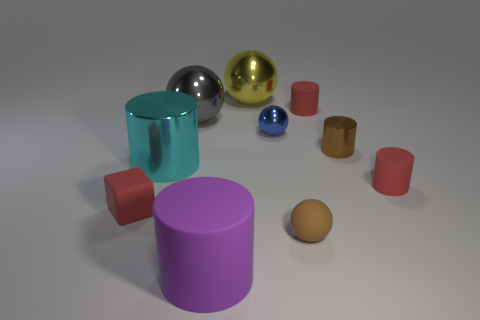Are there any red rubber cubes in front of the red matte object left of the tiny brown rubber thing?
Make the answer very short. No. What number of other things are there of the same color as the tiny rubber cube?
Your answer should be very brief. 2. The rubber ball is what color?
Provide a short and direct response. Brown. How big is the thing that is both behind the big purple cylinder and in front of the red block?
Your answer should be compact. Small. What number of objects are matte objects right of the cyan metallic object or big blue cubes?
Make the answer very short. 4. There is a purple thing that is made of the same material as the red cube; what is its shape?
Your answer should be compact. Cylinder. What is the shape of the purple rubber thing?
Your response must be concise. Cylinder. What is the color of the sphere that is on the left side of the blue object and in front of the yellow metal object?
Your answer should be very brief. Gray. The brown matte thing that is the same size as the brown cylinder is what shape?
Your response must be concise. Sphere. Is there a large gray shiny thing of the same shape as the cyan object?
Provide a succinct answer. No. 